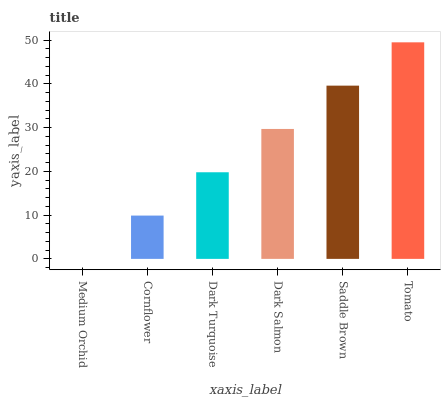Is Medium Orchid the minimum?
Answer yes or no. Yes. Is Tomato the maximum?
Answer yes or no. Yes. Is Cornflower the minimum?
Answer yes or no. No. Is Cornflower the maximum?
Answer yes or no. No. Is Cornflower greater than Medium Orchid?
Answer yes or no. Yes. Is Medium Orchid less than Cornflower?
Answer yes or no. Yes. Is Medium Orchid greater than Cornflower?
Answer yes or no. No. Is Cornflower less than Medium Orchid?
Answer yes or no. No. Is Dark Salmon the high median?
Answer yes or no. Yes. Is Dark Turquoise the low median?
Answer yes or no. Yes. Is Saddle Brown the high median?
Answer yes or no. No. Is Medium Orchid the low median?
Answer yes or no. No. 